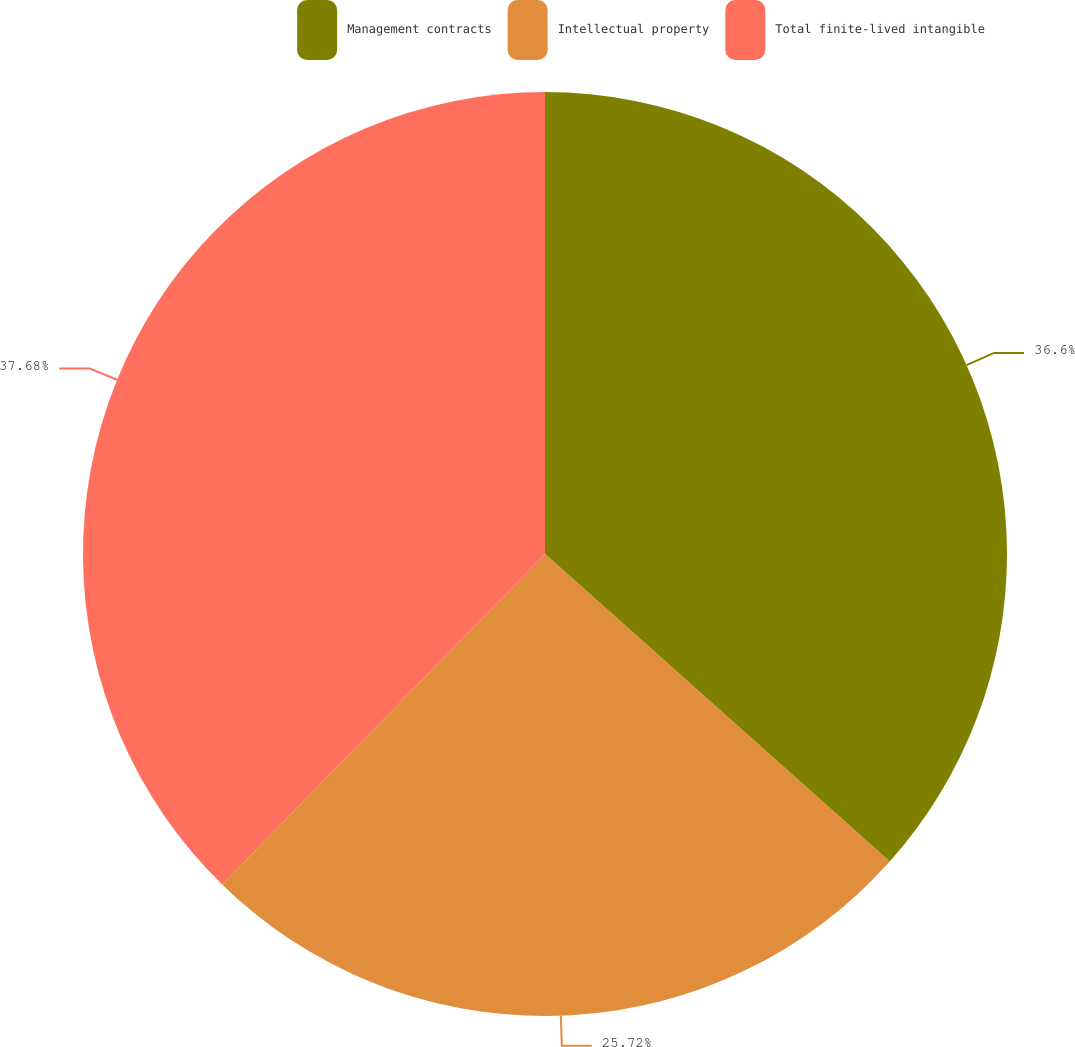<chart> <loc_0><loc_0><loc_500><loc_500><pie_chart><fcel>Management contracts<fcel>Intellectual property<fcel>Total finite-lived intangible<nl><fcel>36.6%<fcel>25.72%<fcel>37.69%<nl></chart> 